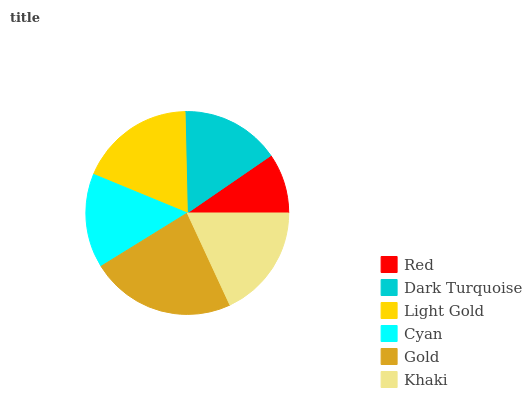Is Red the minimum?
Answer yes or no. Yes. Is Gold the maximum?
Answer yes or no. Yes. Is Dark Turquoise the minimum?
Answer yes or no. No. Is Dark Turquoise the maximum?
Answer yes or no. No. Is Dark Turquoise greater than Red?
Answer yes or no. Yes. Is Red less than Dark Turquoise?
Answer yes or no. Yes. Is Red greater than Dark Turquoise?
Answer yes or no. No. Is Dark Turquoise less than Red?
Answer yes or no. No. Is Khaki the high median?
Answer yes or no. Yes. Is Dark Turquoise the low median?
Answer yes or no. Yes. Is Dark Turquoise the high median?
Answer yes or no. No. Is Cyan the low median?
Answer yes or no. No. 